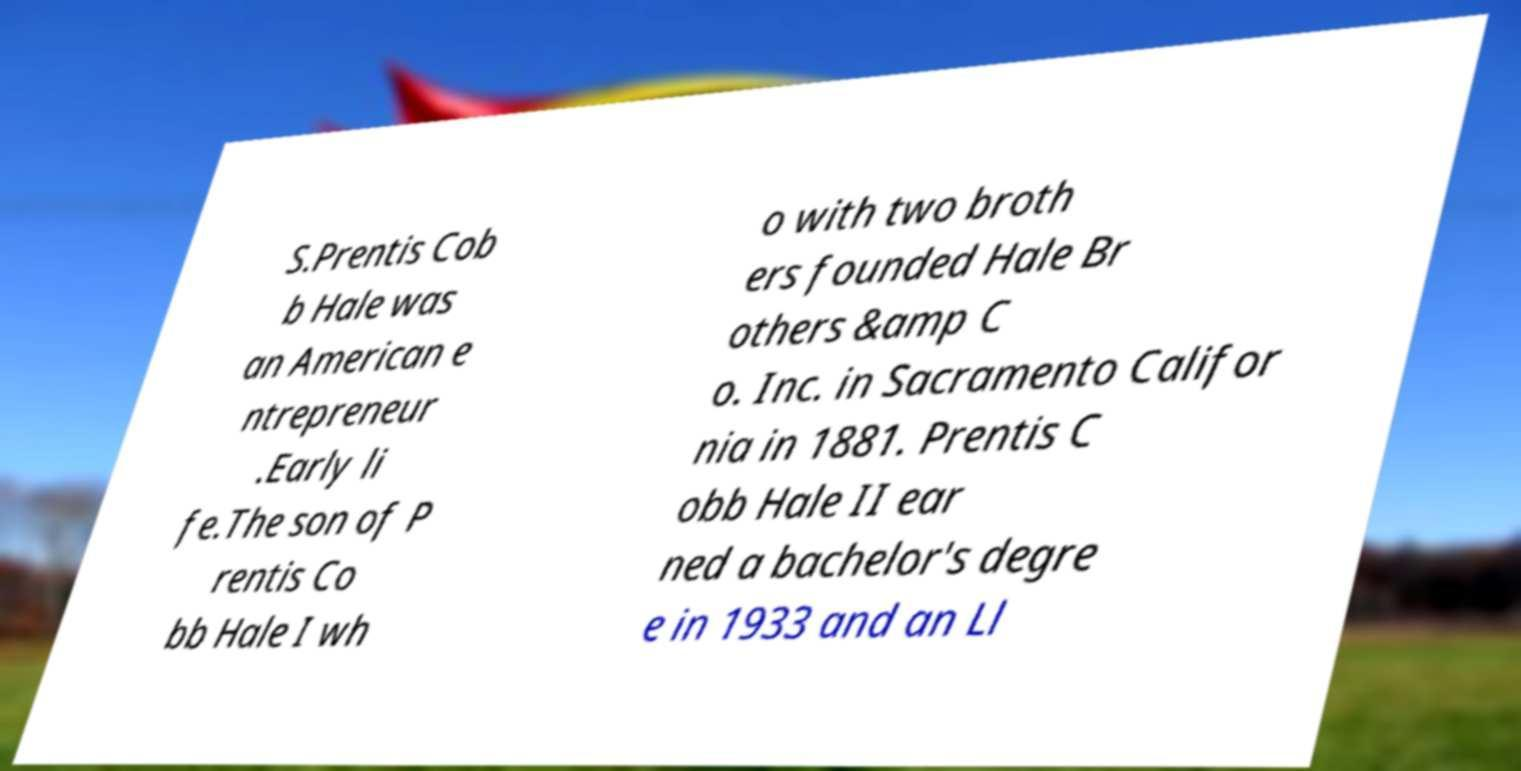Could you extract and type out the text from this image? S.Prentis Cob b Hale was an American e ntrepreneur .Early li fe.The son of P rentis Co bb Hale I wh o with two broth ers founded Hale Br others &amp C o. Inc. in Sacramento Califor nia in 1881. Prentis C obb Hale II ear ned a bachelor's degre e in 1933 and an Ll 